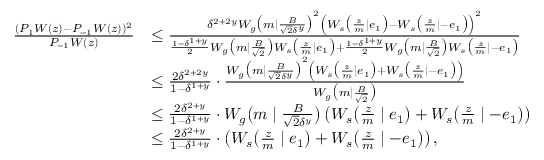<formula> <loc_0><loc_0><loc_500><loc_500>\begin{array} { r l } { \frac { ( P _ { 1 } W ( z ) - P _ { - 1 } W ( z ) ) ^ { 2 } } { P _ { - 1 } W ( z ) } } & { \leq \frac { \delta ^ { 2 + 2 y } W _ { g } \left ( m | \frac { B } { \sqrt { 2 } \delta ^ { y } } \right ) ^ { 2 } \left ( W _ { s } \left ( \frac { z } { m } | e _ { 1 } \right ) - W _ { s } \left ( \frac { z } { m } | - e _ { 1 } \right ) \right ) ^ { 2 } } { \frac { 1 - \delta ^ { 1 + y } } { 2 } W _ { g } \left ( m | \frac { B } { \sqrt { 2 } } \right ) W _ { s } \left ( \frac { z } { m } | e _ { 1 } \right ) + \frac { 1 - \delta ^ { 1 + y } } { 2 } W _ { g } \left ( m | \frac { B } { \sqrt { 2 } } \right ) W _ { s } \left ( \frac { z } { m } | - e _ { 1 } \right ) } } \\ & { \leq \frac { 2 \delta ^ { 2 + 2 y } } { 1 - \delta ^ { 1 + y } } \cdot \frac { W _ { g } \left ( m | \frac { B } { \sqrt { 2 } \delta ^ { y } } \right ) ^ { 2 } \left ( W _ { s } \left ( \frac { z } { m } | e _ { 1 } \right ) + W _ { s } \left ( \frac { z } { m } | - e _ { 1 } \right ) \right ) } { W _ { g } \left ( m | \frac { B } { \sqrt { 2 } } \right ) } } \\ & { \leq \frac { 2 \delta ^ { 2 + y } } { 1 - \delta ^ { 1 + y } } \cdot W _ { g } \left ( m | \frac { B } { \sqrt { 2 } \delta ^ { y } } \right ) \left ( W _ { s } \left ( \frac { z } { m } | e _ { 1 } \right ) + W _ { s } \left ( \frac { z } { m } | - e _ { 1 } \right ) \right ) } \\ & { \leq \frac { 2 \delta ^ { 2 + y } } { 1 - \delta ^ { 1 + y } } \cdot \left ( W _ { s } \left ( \frac { z } { m } | e _ { 1 } \right ) + W _ { s } \left ( \frac { z } { m } | - e _ { 1 } \right ) \right ) , } \end{array}</formula> 